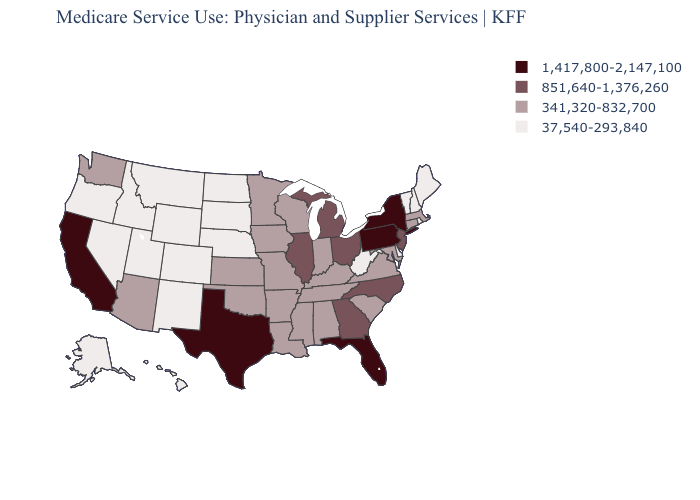Name the states that have a value in the range 851,640-1,376,260?
Be succinct. Georgia, Illinois, Michigan, New Jersey, North Carolina, Ohio. What is the value of Georgia?
Keep it brief. 851,640-1,376,260. What is the lowest value in the USA?
Give a very brief answer. 37,540-293,840. What is the highest value in the USA?
Keep it brief. 1,417,800-2,147,100. Which states hav the highest value in the MidWest?
Write a very short answer. Illinois, Michigan, Ohio. Which states hav the highest value in the Northeast?
Answer briefly. New York, Pennsylvania. Which states have the lowest value in the MidWest?
Quick response, please. Nebraska, North Dakota, South Dakota. Name the states that have a value in the range 1,417,800-2,147,100?
Give a very brief answer. California, Florida, New York, Pennsylvania, Texas. Name the states that have a value in the range 37,540-293,840?
Answer briefly. Alaska, Colorado, Delaware, Hawaii, Idaho, Maine, Montana, Nebraska, Nevada, New Hampshire, New Mexico, North Dakota, Oregon, Rhode Island, South Dakota, Utah, Vermont, West Virginia, Wyoming. What is the value of Ohio?
Answer briefly. 851,640-1,376,260. Does the first symbol in the legend represent the smallest category?
Short answer required. No. Name the states that have a value in the range 341,320-832,700?
Be succinct. Alabama, Arizona, Arkansas, Connecticut, Indiana, Iowa, Kansas, Kentucky, Louisiana, Maryland, Massachusetts, Minnesota, Mississippi, Missouri, Oklahoma, South Carolina, Tennessee, Virginia, Washington, Wisconsin. Name the states that have a value in the range 851,640-1,376,260?
Be succinct. Georgia, Illinois, Michigan, New Jersey, North Carolina, Ohio. Does the map have missing data?
Give a very brief answer. No. What is the value of South Dakota?
Answer briefly. 37,540-293,840. 